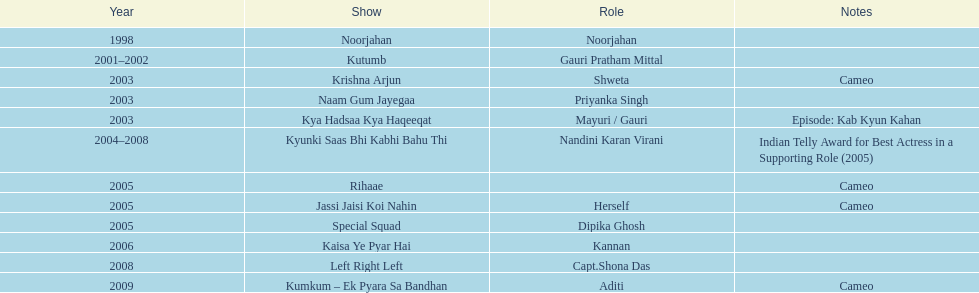How many shows were there in 2005? 3. 